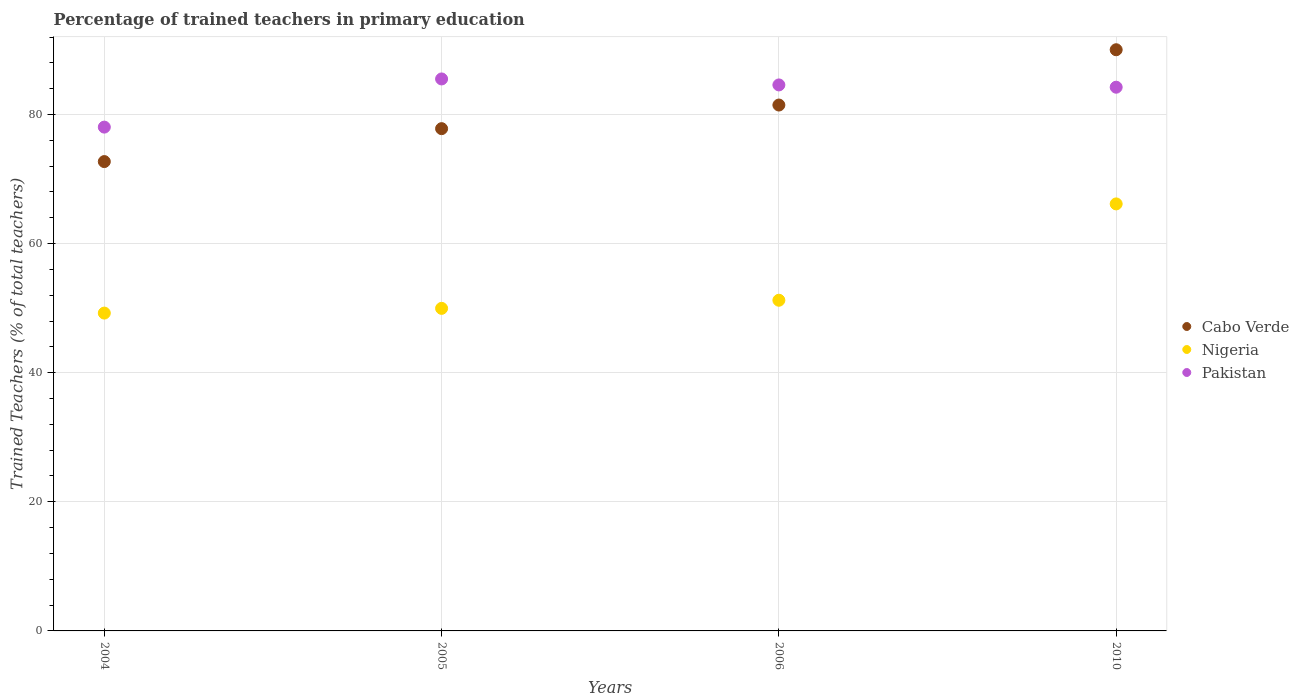How many different coloured dotlines are there?
Your answer should be compact. 3. Is the number of dotlines equal to the number of legend labels?
Offer a terse response. Yes. What is the percentage of trained teachers in Pakistan in 2005?
Keep it short and to the point. 85.51. Across all years, what is the maximum percentage of trained teachers in Cabo Verde?
Keep it short and to the point. 90.03. Across all years, what is the minimum percentage of trained teachers in Cabo Verde?
Ensure brevity in your answer.  72.7. In which year was the percentage of trained teachers in Cabo Verde maximum?
Offer a very short reply. 2010. What is the total percentage of trained teachers in Pakistan in the graph?
Offer a terse response. 332.36. What is the difference between the percentage of trained teachers in Cabo Verde in 2006 and that in 2010?
Your answer should be very brief. -8.57. What is the difference between the percentage of trained teachers in Pakistan in 2004 and the percentage of trained teachers in Cabo Verde in 2010?
Offer a terse response. -11.99. What is the average percentage of trained teachers in Nigeria per year?
Give a very brief answer. 54.14. In the year 2005, what is the difference between the percentage of trained teachers in Pakistan and percentage of trained teachers in Cabo Verde?
Your response must be concise. 7.7. What is the ratio of the percentage of trained teachers in Cabo Verde in 2006 to that in 2010?
Ensure brevity in your answer.  0.9. What is the difference between the highest and the second highest percentage of trained teachers in Pakistan?
Keep it short and to the point. 0.93. What is the difference between the highest and the lowest percentage of trained teachers in Cabo Verde?
Ensure brevity in your answer.  17.33. In how many years, is the percentage of trained teachers in Pakistan greater than the average percentage of trained teachers in Pakistan taken over all years?
Make the answer very short. 3. Is the sum of the percentage of trained teachers in Pakistan in 2004 and 2006 greater than the maximum percentage of trained teachers in Cabo Verde across all years?
Give a very brief answer. Yes. Does the percentage of trained teachers in Nigeria monotonically increase over the years?
Your answer should be compact. Yes. Is the percentage of trained teachers in Nigeria strictly greater than the percentage of trained teachers in Pakistan over the years?
Give a very brief answer. No. How many dotlines are there?
Provide a succinct answer. 3. How many years are there in the graph?
Give a very brief answer. 4. What is the difference between two consecutive major ticks on the Y-axis?
Your answer should be compact. 20. Are the values on the major ticks of Y-axis written in scientific E-notation?
Offer a very short reply. No. How are the legend labels stacked?
Your answer should be compact. Vertical. What is the title of the graph?
Offer a very short reply. Percentage of trained teachers in primary education. Does "New Caledonia" appear as one of the legend labels in the graph?
Offer a very short reply. No. What is the label or title of the Y-axis?
Provide a succinct answer. Trained Teachers (% of total teachers). What is the Trained Teachers (% of total teachers) of Cabo Verde in 2004?
Your answer should be very brief. 72.7. What is the Trained Teachers (% of total teachers) of Nigeria in 2004?
Your answer should be very brief. 49.24. What is the Trained Teachers (% of total teachers) in Pakistan in 2004?
Ensure brevity in your answer.  78.04. What is the Trained Teachers (% of total teachers) of Cabo Verde in 2005?
Your answer should be very brief. 77.81. What is the Trained Teachers (% of total teachers) in Nigeria in 2005?
Keep it short and to the point. 49.97. What is the Trained Teachers (% of total teachers) in Pakistan in 2005?
Offer a very short reply. 85.51. What is the Trained Teachers (% of total teachers) of Cabo Verde in 2006?
Provide a succinct answer. 81.46. What is the Trained Teachers (% of total teachers) of Nigeria in 2006?
Your answer should be very brief. 51.22. What is the Trained Teachers (% of total teachers) in Pakistan in 2006?
Offer a terse response. 84.58. What is the Trained Teachers (% of total teachers) in Cabo Verde in 2010?
Offer a terse response. 90.03. What is the Trained Teachers (% of total teachers) in Nigeria in 2010?
Provide a short and direct response. 66.15. What is the Trained Teachers (% of total teachers) of Pakistan in 2010?
Offer a terse response. 84.23. Across all years, what is the maximum Trained Teachers (% of total teachers) of Cabo Verde?
Give a very brief answer. 90.03. Across all years, what is the maximum Trained Teachers (% of total teachers) of Nigeria?
Your response must be concise. 66.15. Across all years, what is the maximum Trained Teachers (% of total teachers) in Pakistan?
Ensure brevity in your answer.  85.51. Across all years, what is the minimum Trained Teachers (% of total teachers) in Cabo Verde?
Provide a short and direct response. 72.7. Across all years, what is the minimum Trained Teachers (% of total teachers) in Nigeria?
Provide a succinct answer. 49.24. Across all years, what is the minimum Trained Teachers (% of total teachers) in Pakistan?
Make the answer very short. 78.04. What is the total Trained Teachers (% of total teachers) of Cabo Verde in the graph?
Provide a short and direct response. 322. What is the total Trained Teachers (% of total teachers) in Nigeria in the graph?
Ensure brevity in your answer.  216.58. What is the total Trained Teachers (% of total teachers) of Pakistan in the graph?
Keep it short and to the point. 332.36. What is the difference between the Trained Teachers (% of total teachers) in Cabo Verde in 2004 and that in 2005?
Offer a very short reply. -5.1. What is the difference between the Trained Teachers (% of total teachers) in Nigeria in 2004 and that in 2005?
Ensure brevity in your answer.  -0.73. What is the difference between the Trained Teachers (% of total teachers) in Pakistan in 2004 and that in 2005?
Offer a very short reply. -7.46. What is the difference between the Trained Teachers (% of total teachers) of Cabo Verde in 2004 and that in 2006?
Keep it short and to the point. -8.76. What is the difference between the Trained Teachers (% of total teachers) in Nigeria in 2004 and that in 2006?
Your response must be concise. -1.99. What is the difference between the Trained Teachers (% of total teachers) of Pakistan in 2004 and that in 2006?
Ensure brevity in your answer.  -6.54. What is the difference between the Trained Teachers (% of total teachers) of Cabo Verde in 2004 and that in 2010?
Ensure brevity in your answer.  -17.33. What is the difference between the Trained Teachers (% of total teachers) in Nigeria in 2004 and that in 2010?
Provide a succinct answer. -16.91. What is the difference between the Trained Teachers (% of total teachers) of Pakistan in 2004 and that in 2010?
Ensure brevity in your answer.  -6.18. What is the difference between the Trained Teachers (% of total teachers) in Cabo Verde in 2005 and that in 2006?
Your response must be concise. -3.66. What is the difference between the Trained Teachers (% of total teachers) in Nigeria in 2005 and that in 2006?
Give a very brief answer. -1.26. What is the difference between the Trained Teachers (% of total teachers) in Pakistan in 2005 and that in 2006?
Offer a very short reply. 0.93. What is the difference between the Trained Teachers (% of total teachers) in Cabo Verde in 2005 and that in 2010?
Ensure brevity in your answer.  -12.22. What is the difference between the Trained Teachers (% of total teachers) in Nigeria in 2005 and that in 2010?
Ensure brevity in your answer.  -16.18. What is the difference between the Trained Teachers (% of total teachers) in Pakistan in 2005 and that in 2010?
Make the answer very short. 1.28. What is the difference between the Trained Teachers (% of total teachers) in Cabo Verde in 2006 and that in 2010?
Make the answer very short. -8.57. What is the difference between the Trained Teachers (% of total teachers) of Nigeria in 2006 and that in 2010?
Make the answer very short. -14.92. What is the difference between the Trained Teachers (% of total teachers) in Pakistan in 2006 and that in 2010?
Your response must be concise. 0.35. What is the difference between the Trained Teachers (% of total teachers) of Cabo Verde in 2004 and the Trained Teachers (% of total teachers) of Nigeria in 2005?
Provide a succinct answer. 22.74. What is the difference between the Trained Teachers (% of total teachers) in Cabo Verde in 2004 and the Trained Teachers (% of total teachers) in Pakistan in 2005?
Your answer should be very brief. -12.8. What is the difference between the Trained Teachers (% of total teachers) in Nigeria in 2004 and the Trained Teachers (% of total teachers) in Pakistan in 2005?
Offer a very short reply. -36.27. What is the difference between the Trained Teachers (% of total teachers) of Cabo Verde in 2004 and the Trained Teachers (% of total teachers) of Nigeria in 2006?
Provide a succinct answer. 21.48. What is the difference between the Trained Teachers (% of total teachers) of Cabo Verde in 2004 and the Trained Teachers (% of total teachers) of Pakistan in 2006?
Provide a succinct answer. -11.88. What is the difference between the Trained Teachers (% of total teachers) in Nigeria in 2004 and the Trained Teachers (% of total teachers) in Pakistan in 2006?
Provide a short and direct response. -35.34. What is the difference between the Trained Teachers (% of total teachers) in Cabo Verde in 2004 and the Trained Teachers (% of total teachers) in Nigeria in 2010?
Make the answer very short. 6.56. What is the difference between the Trained Teachers (% of total teachers) of Cabo Verde in 2004 and the Trained Teachers (% of total teachers) of Pakistan in 2010?
Your response must be concise. -11.52. What is the difference between the Trained Teachers (% of total teachers) of Nigeria in 2004 and the Trained Teachers (% of total teachers) of Pakistan in 2010?
Provide a short and direct response. -34.99. What is the difference between the Trained Teachers (% of total teachers) of Cabo Verde in 2005 and the Trained Teachers (% of total teachers) of Nigeria in 2006?
Your answer should be very brief. 26.58. What is the difference between the Trained Teachers (% of total teachers) of Cabo Verde in 2005 and the Trained Teachers (% of total teachers) of Pakistan in 2006?
Make the answer very short. -6.77. What is the difference between the Trained Teachers (% of total teachers) in Nigeria in 2005 and the Trained Teachers (% of total teachers) in Pakistan in 2006?
Keep it short and to the point. -34.61. What is the difference between the Trained Teachers (% of total teachers) in Cabo Verde in 2005 and the Trained Teachers (% of total teachers) in Nigeria in 2010?
Your response must be concise. 11.66. What is the difference between the Trained Teachers (% of total teachers) in Cabo Verde in 2005 and the Trained Teachers (% of total teachers) in Pakistan in 2010?
Offer a very short reply. -6.42. What is the difference between the Trained Teachers (% of total teachers) in Nigeria in 2005 and the Trained Teachers (% of total teachers) in Pakistan in 2010?
Offer a very short reply. -34.26. What is the difference between the Trained Teachers (% of total teachers) of Cabo Verde in 2006 and the Trained Teachers (% of total teachers) of Nigeria in 2010?
Your answer should be very brief. 15.32. What is the difference between the Trained Teachers (% of total teachers) in Cabo Verde in 2006 and the Trained Teachers (% of total teachers) in Pakistan in 2010?
Offer a very short reply. -2.76. What is the difference between the Trained Teachers (% of total teachers) in Nigeria in 2006 and the Trained Teachers (% of total teachers) in Pakistan in 2010?
Provide a succinct answer. -33. What is the average Trained Teachers (% of total teachers) of Cabo Verde per year?
Your answer should be very brief. 80.5. What is the average Trained Teachers (% of total teachers) of Nigeria per year?
Your answer should be very brief. 54.14. What is the average Trained Teachers (% of total teachers) in Pakistan per year?
Your answer should be compact. 83.09. In the year 2004, what is the difference between the Trained Teachers (% of total teachers) in Cabo Verde and Trained Teachers (% of total teachers) in Nigeria?
Provide a succinct answer. 23.47. In the year 2004, what is the difference between the Trained Teachers (% of total teachers) of Cabo Verde and Trained Teachers (% of total teachers) of Pakistan?
Give a very brief answer. -5.34. In the year 2004, what is the difference between the Trained Teachers (% of total teachers) of Nigeria and Trained Teachers (% of total teachers) of Pakistan?
Ensure brevity in your answer.  -28.81. In the year 2005, what is the difference between the Trained Teachers (% of total teachers) of Cabo Verde and Trained Teachers (% of total teachers) of Nigeria?
Make the answer very short. 27.84. In the year 2005, what is the difference between the Trained Teachers (% of total teachers) of Cabo Verde and Trained Teachers (% of total teachers) of Pakistan?
Your response must be concise. -7.7. In the year 2005, what is the difference between the Trained Teachers (% of total teachers) in Nigeria and Trained Teachers (% of total teachers) in Pakistan?
Make the answer very short. -35.54. In the year 2006, what is the difference between the Trained Teachers (% of total teachers) of Cabo Verde and Trained Teachers (% of total teachers) of Nigeria?
Provide a short and direct response. 30.24. In the year 2006, what is the difference between the Trained Teachers (% of total teachers) of Cabo Verde and Trained Teachers (% of total teachers) of Pakistan?
Provide a succinct answer. -3.12. In the year 2006, what is the difference between the Trained Teachers (% of total teachers) in Nigeria and Trained Teachers (% of total teachers) in Pakistan?
Give a very brief answer. -33.35. In the year 2010, what is the difference between the Trained Teachers (% of total teachers) of Cabo Verde and Trained Teachers (% of total teachers) of Nigeria?
Your response must be concise. 23.88. In the year 2010, what is the difference between the Trained Teachers (% of total teachers) of Cabo Verde and Trained Teachers (% of total teachers) of Pakistan?
Provide a succinct answer. 5.8. In the year 2010, what is the difference between the Trained Teachers (% of total teachers) in Nigeria and Trained Teachers (% of total teachers) in Pakistan?
Provide a short and direct response. -18.08. What is the ratio of the Trained Teachers (% of total teachers) of Cabo Verde in 2004 to that in 2005?
Offer a terse response. 0.93. What is the ratio of the Trained Teachers (% of total teachers) of Nigeria in 2004 to that in 2005?
Provide a short and direct response. 0.99. What is the ratio of the Trained Teachers (% of total teachers) in Pakistan in 2004 to that in 2005?
Offer a terse response. 0.91. What is the ratio of the Trained Teachers (% of total teachers) in Cabo Verde in 2004 to that in 2006?
Give a very brief answer. 0.89. What is the ratio of the Trained Teachers (% of total teachers) of Nigeria in 2004 to that in 2006?
Provide a short and direct response. 0.96. What is the ratio of the Trained Teachers (% of total teachers) in Pakistan in 2004 to that in 2006?
Ensure brevity in your answer.  0.92. What is the ratio of the Trained Teachers (% of total teachers) in Cabo Verde in 2004 to that in 2010?
Keep it short and to the point. 0.81. What is the ratio of the Trained Teachers (% of total teachers) in Nigeria in 2004 to that in 2010?
Your answer should be very brief. 0.74. What is the ratio of the Trained Teachers (% of total teachers) in Pakistan in 2004 to that in 2010?
Provide a short and direct response. 0.93. What is the ratio of the Trained Teachers (% of total teachers) in Cabo Verde in 2005 to that in 2006?
Ensure brevity in your answer.  0.96. What is the ratio of the Trained Teachers (% of total teachers) of Nigeria in 2005 to that in 2006?
Your answer should be compact. 0.98. What is the ratio of the Trained Teachers (% of total teachers) of Cabo Verde in 2005 to that in 2010?
Provide a succinct answer. 0.86. What is the ratio of the Trained Teachers (% of total teachers) of Nigeria in 2005 to that in 2010?
Your answer should be very brief. 0.76. What is the ratio of the Trained Teachers (% of total teachers) in Pakistan in 2005 to that in 2010?
Your answer should be compact. 1.02. What is the ratio of the Trained Teachers (% of total teachers) in Cabo Verde in 2006 to that in 2010?
Give a very brief answer. 0.9. What is the ratio of the Trained Teachers (% of total teachers) in Nigeria in 2006 to that in 2010?
Your answer should be compact. 0.77. What is the difference between the highest and the second highest Trained Teachers (% of total teachers) of Cabo Verde?
Provide a succinct answer. 8.57. What is the difference between the highest and the second highest Trained Teachers (% of total teachers) in Nigeria?
Your answer should be compact. 14.92. What is the difference between the highest and the second highest Trained Teachers (% of total teachers) of Pakistan?
Provide a short and direct response. 0.93. What is the difference between the highest and the lowest Trained Teachers (% of total teachers) of Cabo Verde?
Your response must be concise. 17.33. What is the difference between the highest and the lowest Trained Teachers (% of total teachers) in Nigeria?
Your response must be concise. 16.91. What is the difference between the highest and the lowest Trained Teachers (% of total teachers) in Pakistan?
Your response must be concise. 7.46. 